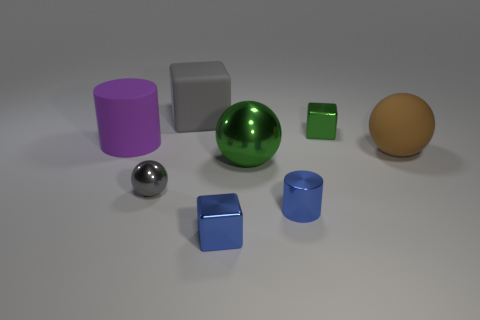Which object in the picture seems out of place compared to the others? None of the objects in the image seem inherently out of place as they all share a similar simple geometric form. However, the small blue cube at the bottom left might seem slightly out of place because it is the only object that is slightly tilted and not aligned perfectly straight like the others. 